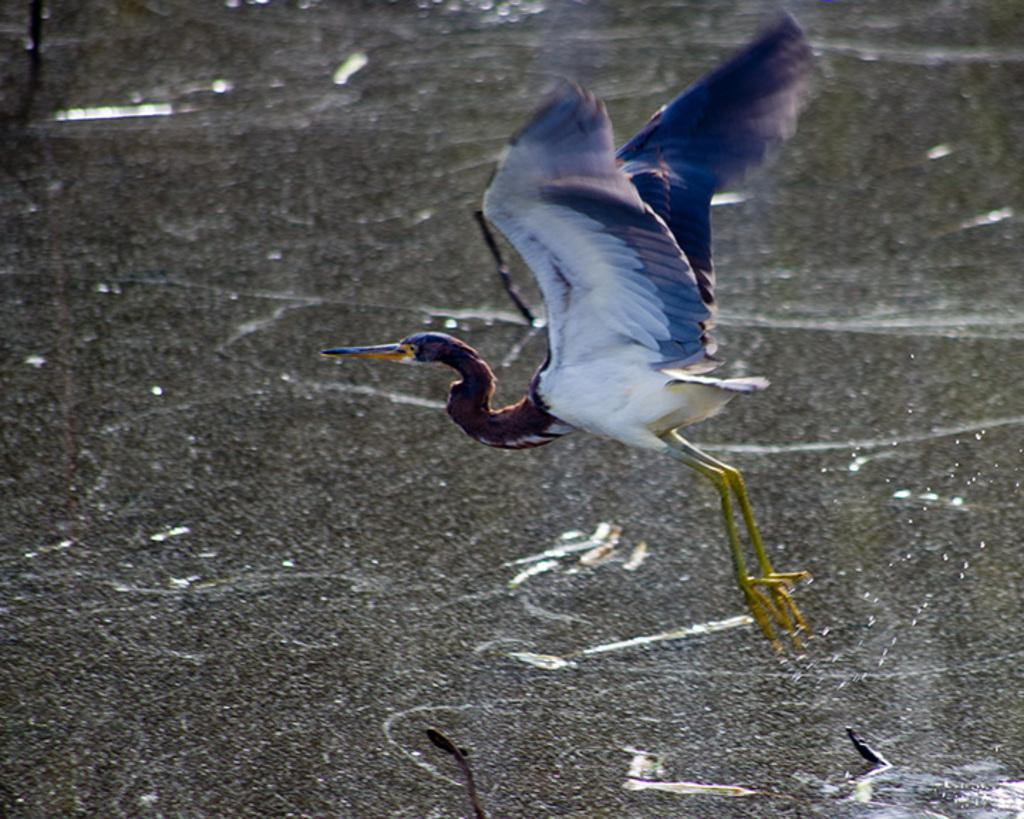What type of animal can be seen in the image? There is a bird in the image. What is visible in the background of the image? There is a water surface visible in the background of the image. What advice does the monkey give to the bird in the image? There is no monkey present in the image, so it is not possible to answer that question. 